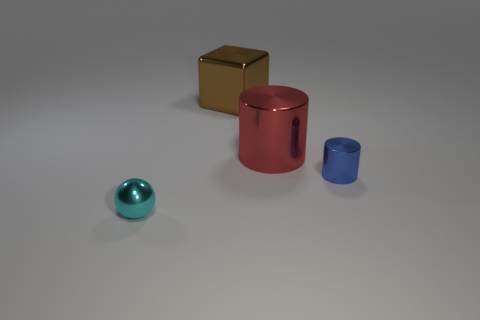Is the blue metallic thing the same size as the cyan metallic thing?
Provide a succinct answer. Yes. There is a small metal cylinder; what number of red objects are behind it?
Offer a terse response. 1. Is the number of objects greater than the number of red things?
Your answer should be compact. Yes. There is a object that is both right of the large brown thing and on the left side of the blue thing; what shape is it?
Provide a succinct answer. Cylinder. Is there a tiny cyan rubber sphere?
Provide a succinct answer. No. There is another object that is the same shape as the big red metal thing; what is it made of?
Provide a succinct answer. Metal. What is the shape of the object left of the thing behind the metallic cylinder that is to the left of the blue object?
Keep it short and to the point. Sphere. How many small blue things are the same shape as the big red object?
Provide a short and direct response. 1. Does the tiny metallic object on the left side of the large brown metallic block have the same color as the tiny thing that is behind the tiny cyan ball?
Make the answer very short. No. There is a red thing that is the same size as the brown object; what is it made of?
Make the answer very short. Metal. 